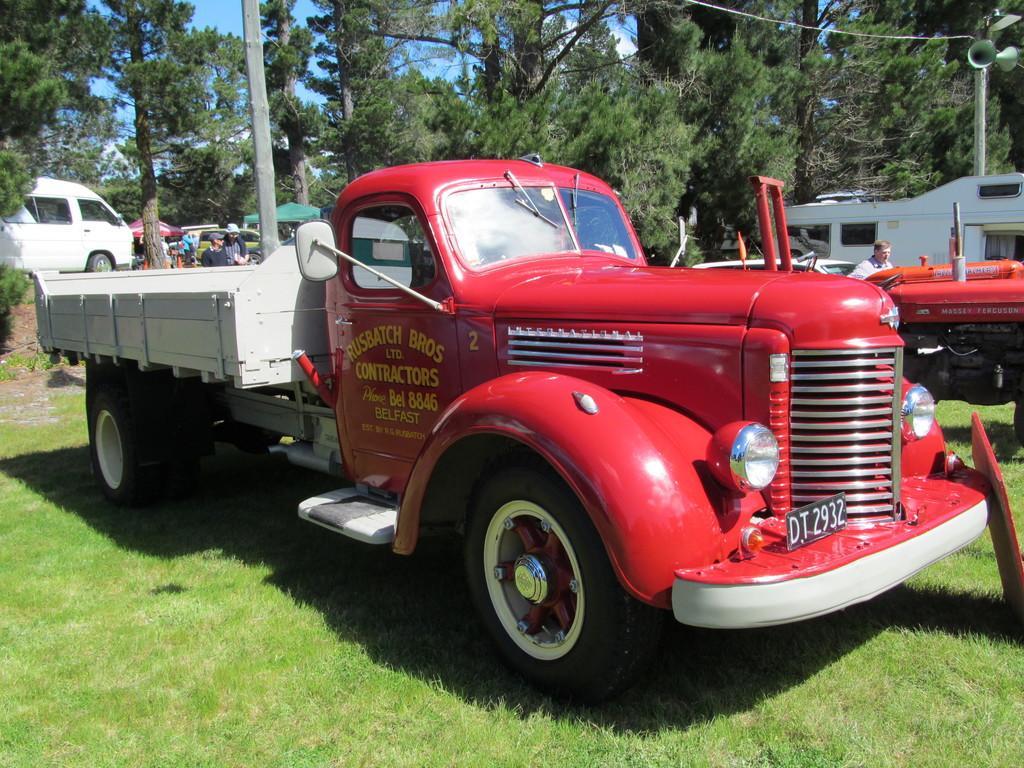How would you summarize this image in a sentence or two? In this picture I can see vehicles, there are group of people standing, there are canopy tents, there are megaphones to a pole, there are trees, and in the background there is sky. 